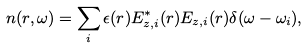<formula> <loc_0><loc_0><loc_500><loc_500>n ( r , \omega ) = \sum _ { i } \epsilon ( r ) E ^ { * } _ { z , i } ( r ) E _ { z , i } ( r ) \delta ( \omega - \omega _ { i } ) ,</formula> 